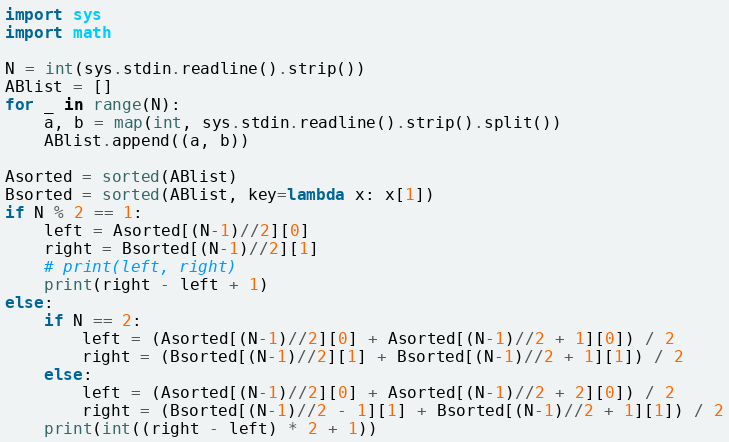Convert code to text. <code><loc_0><loc_0><loc_500><loc_500><_Python_>import sys
import math

N = int(sys.stdin.readline().strip())
ABlist = []
for _ in range(N):
    a, b = map(int, sys.stdin.readline().strip().split())
    ABlist.append((a, b))

Asorted = sorted(ABlist)
Bsorted = sorted(ABlist, key=lambda x: x[1])
if N % 2 == 1:
    left = Asorted[(N-1)//2][0]
    right = Bsorted[(N-1)//2][1]
    # print(left, right)
    print(right - left + 1)
else:
    if N == 2:
        left = (Asorted[(N-1)//2][0] + Asorted[(N-1)//2 + 1][0]) / 2
        right = (Bsorted[(N-1)//2][1] + Bsorted[(N-1)//2 + 1][1]) / 2
    else:
        left = (Asorted[(N-1)//2][0] + Asorted[(N-1)//2 + 2][0]) / 2
        right = (Bsorted[(N-1)//2 - 1][1] + Bsorted[(N-1)//2 + 1][1]) / 2
    print(int((right - left) * 2 + 1))</code> 